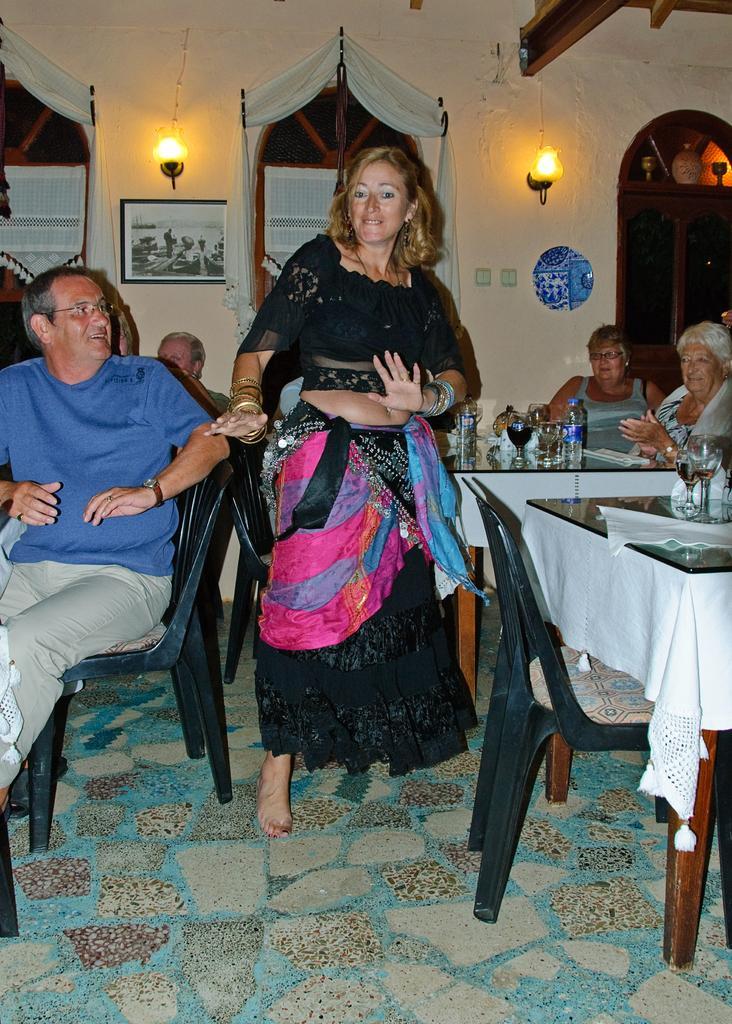How would you summarize this image in a sentence or two? As we can see in the image there are five persons. Two on the left, two on the right and one person in the middle. She is wearing black color dress. In background there is a frame, two lights and white color wall. 